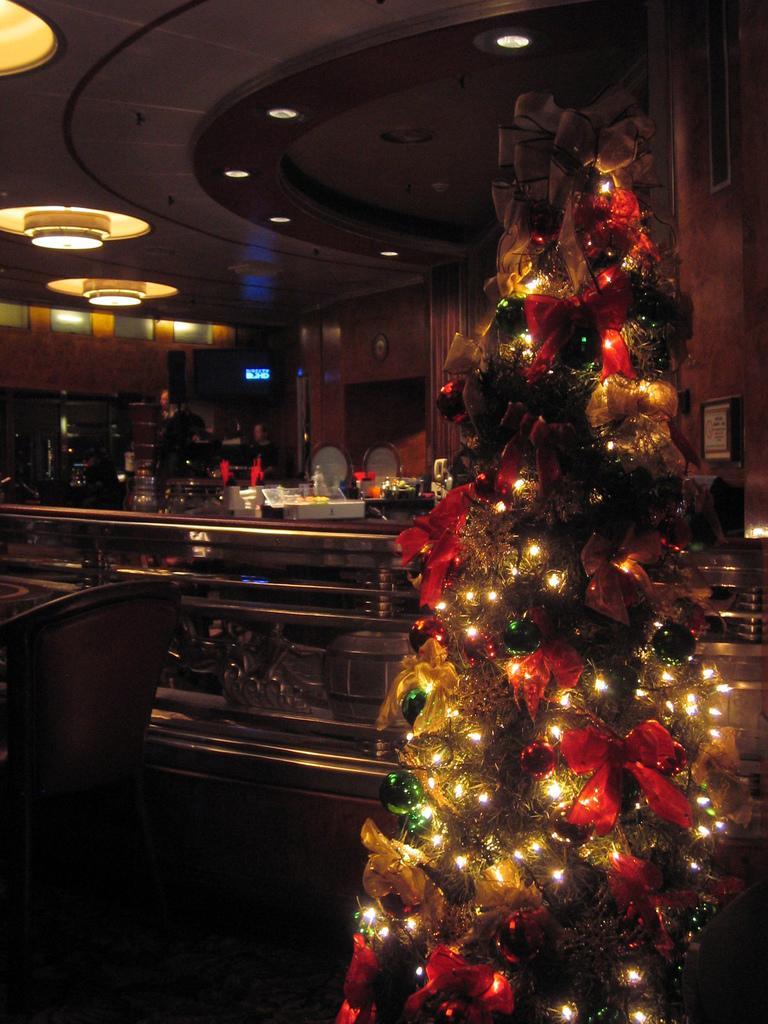In one or two sentences, can you explain what this image depicts? In this picture we can observe a Christmas tree decorated with some lights. We can observe a desk on which there are some bottles placed. In the background there is a wall and we can observe lights in the ceiling. 